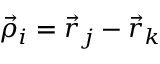Convert formula to latex. <formula><loc_0><loc_0><loc_500><loc_500>\vec { \rho } _ { i } = \vec { r } _ { j } - \vec { r } _ { k }</formula> 